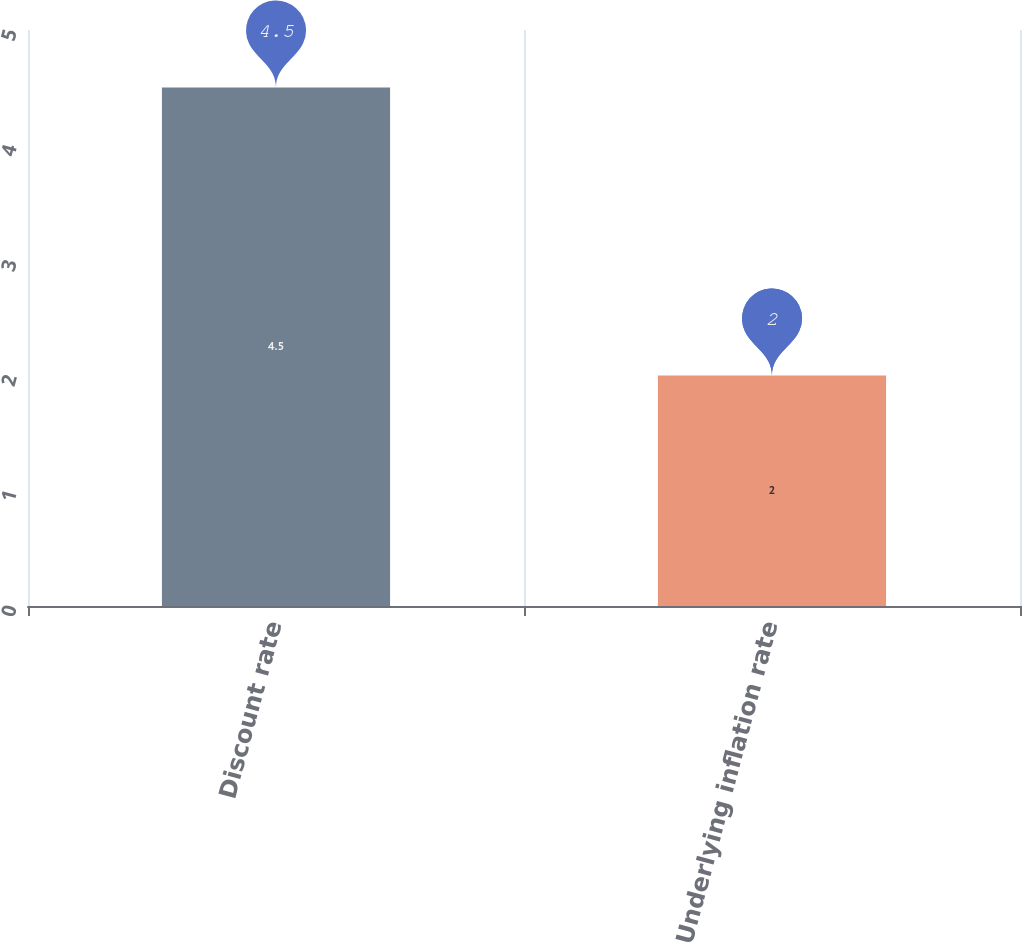<chart> <loc_0><loc_0><loc_500><loc_500><bar_chart><fcel>Discount rate<fcel>Underlying inflation rate<nl><fcel>4.5<fcel>2<nl></chart> 